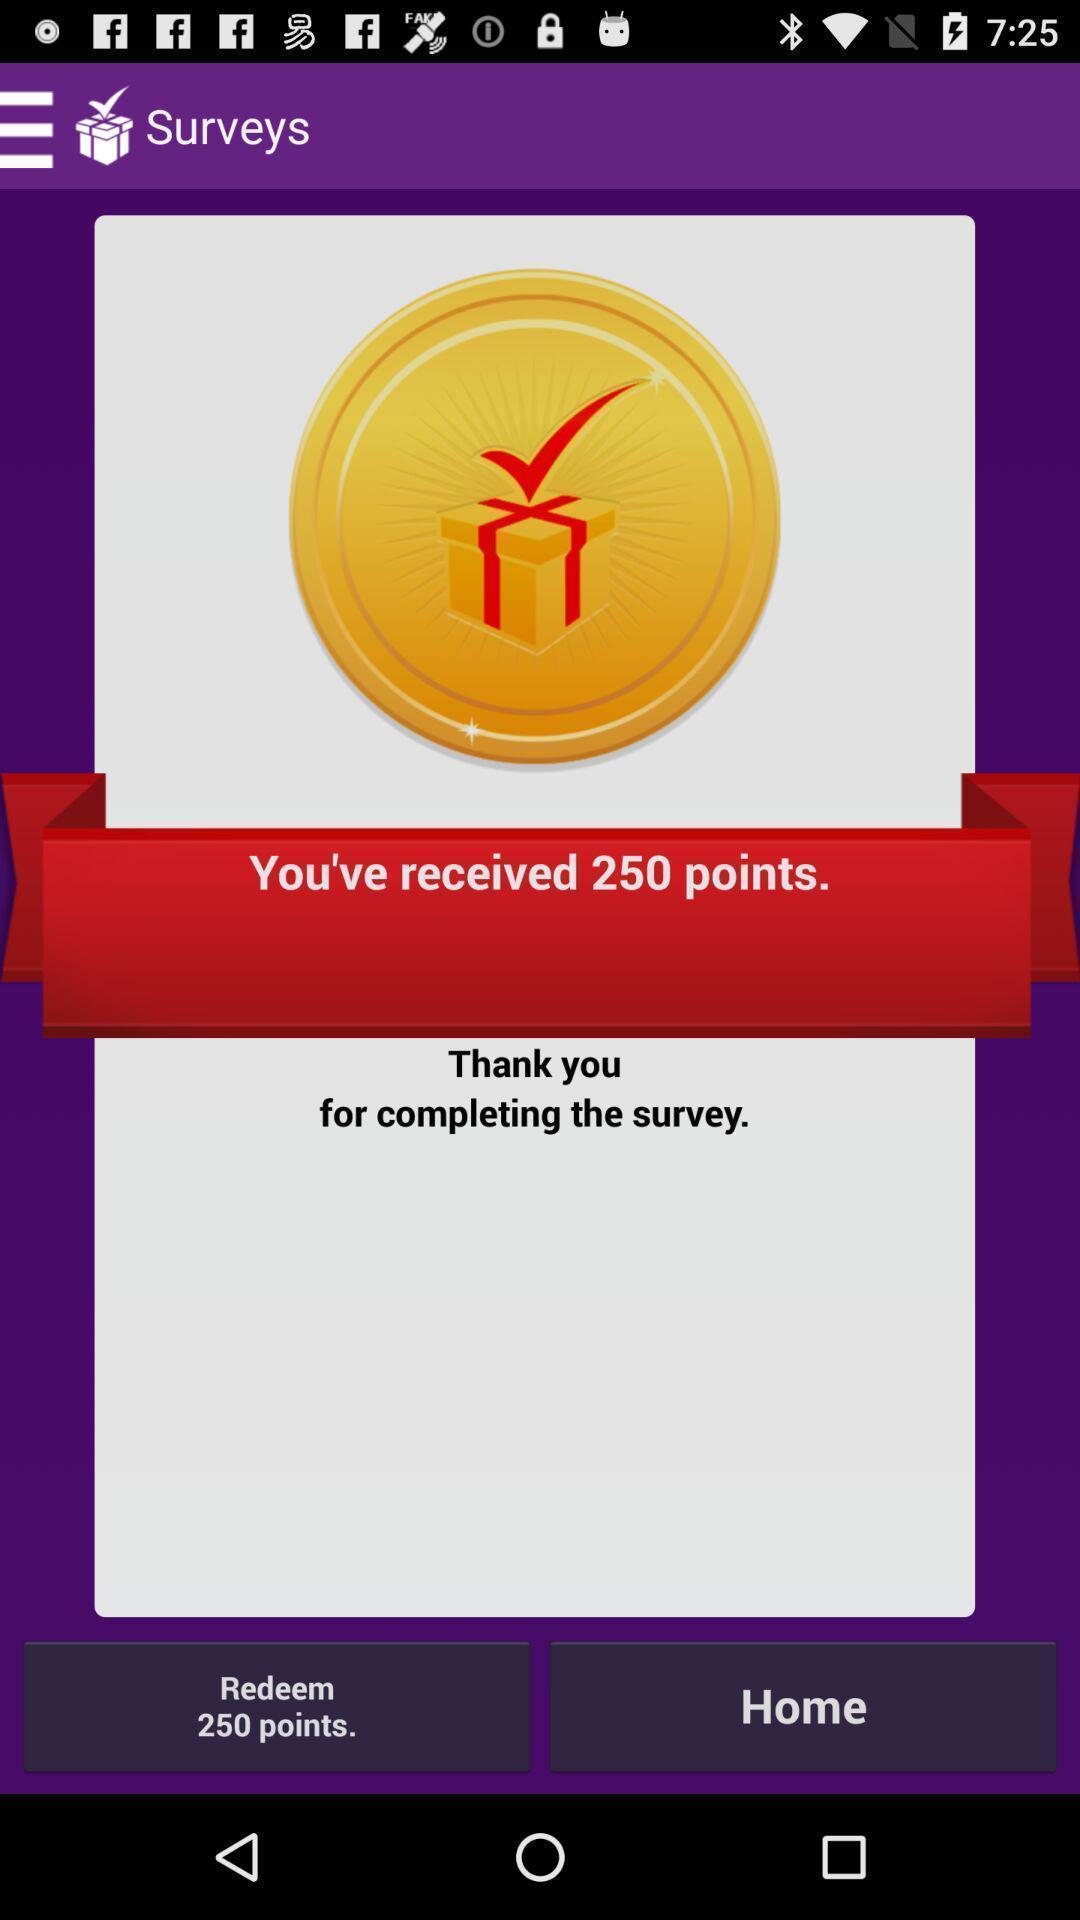Summarize the main components in this picture. Screen displaying contents in rewards page. 